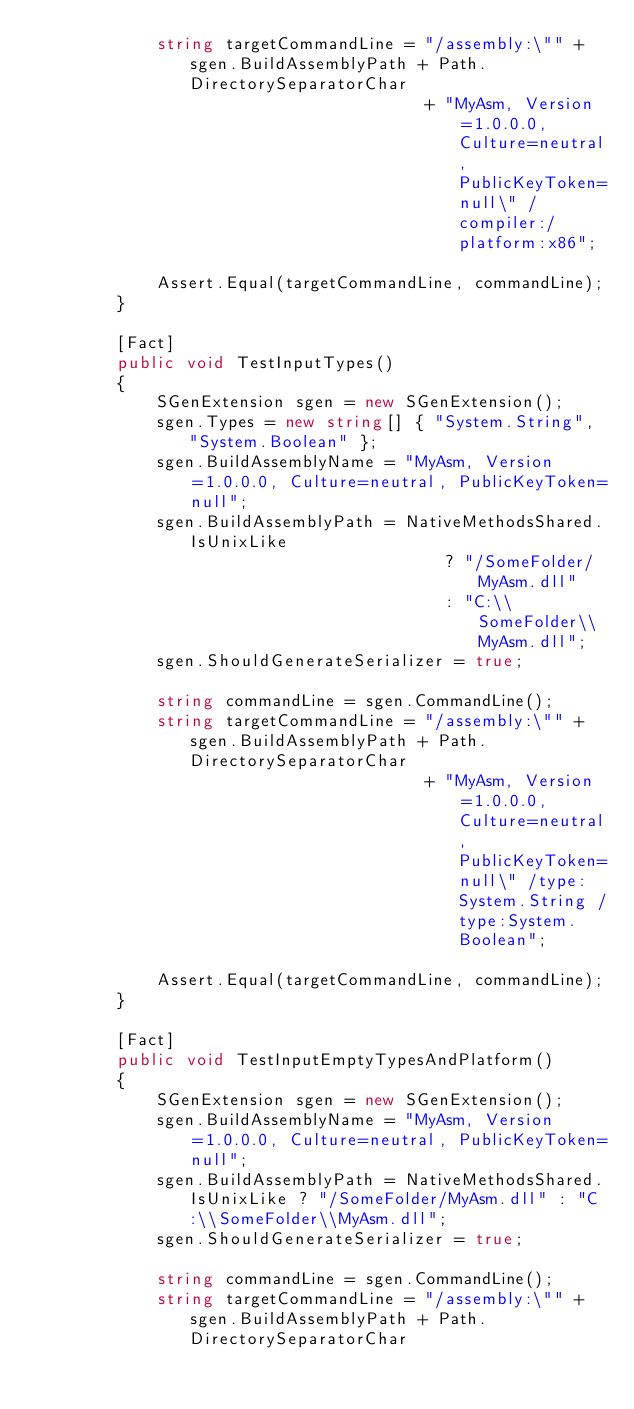Convert code to text. <code><loc_0><loc_0><loc_500><loc_500><_C#_>            string targetCommandLine = "/assembly:\"" + sgen.BuildAssemblyPath + Path.DirectorySeparatorChar
                                       + "MyAsm, Version=1.0.0.0, Culture=neutral, PublicKeyToken=null\" /compiler:/platform:x86";

            Assert.Equal(targetCommandLine, commandLine);
        }

        [Fact]
        public void TestInputTypes()
        {
            SGenExtension sgen = new SGenExtension();
            sgen.Types = new string[] { "System.String", "System.Boolean" };
            sgen.BuildAssemblyName = "MyAsm, Version=1.0.0.0, Culture=neutral, PublicKeyToken=null";
            sgen.BuildAssemblyPath = NativeMethodsShared.IsUnixLike
                                         ? "/SomeFolder/MyAsm.dll"
                                         : "C:\\SomeFolder\\MyAsm.dll";
            sgen.ShouldGenerateSerializer = true;

            string commandLine = sgen.CommandLine();
            string targetCommandLine = "/assembly:\"" + sgen.BuildAssemblyPath + Path.DirectorySeparatorChar
                                       + "MyAsm, Version=1.0.0.0, Culture=neutral, PublicKeyToken=null\" /type:System.String /type:System.Boolean";

            Assert.Equal(targetCommandLine, commandLine);
        }

        [Fact]
        public void TestInputEmptyTypesAndPlatform()
        {
            SGenExtension sgen = new SGenExtension();
            sgen.BuildAssemblyName = "MyAsm, Version=1.0.0.0, Culture=neutral, PublicKeyToken=null";
            sgen.BuildAssemblyPath = NativeMethodsShared.IsUnixLike ? "/SomeFolder/MyAsm.dll" : "C:\\SomeFolder\\MyAsm.dll";
            sgen.ShouldGenerateSerializer = true;

            string commandLine = sgen.CommandLine();
            string targetCommandLine = "/assembly:\"" + sgen.BuildAssemblyPath + Path.DirectorySeparatorChar</code> 